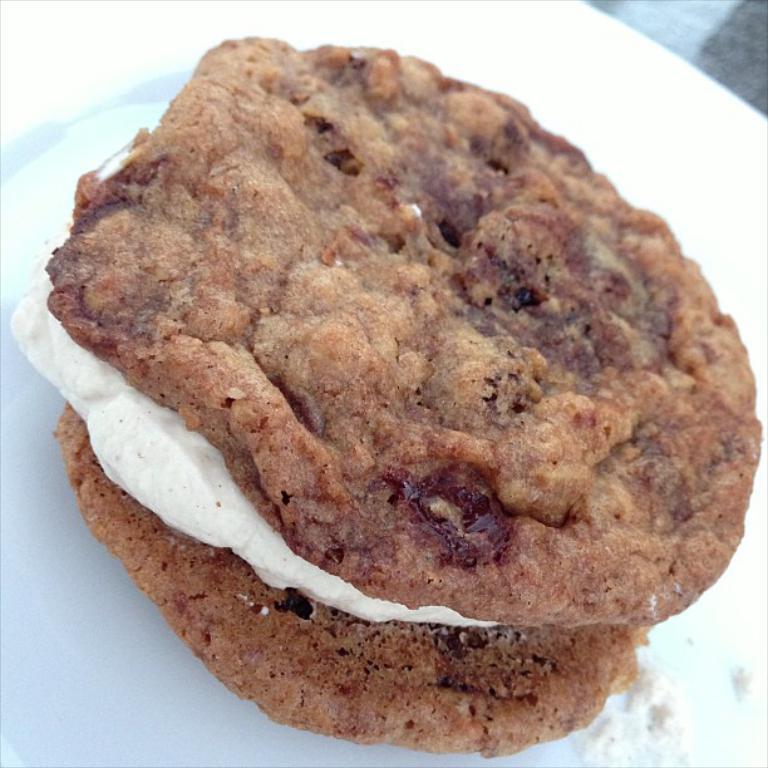Can you describe this image briefly? On this white plate we can see a food. It is brown and white color. 